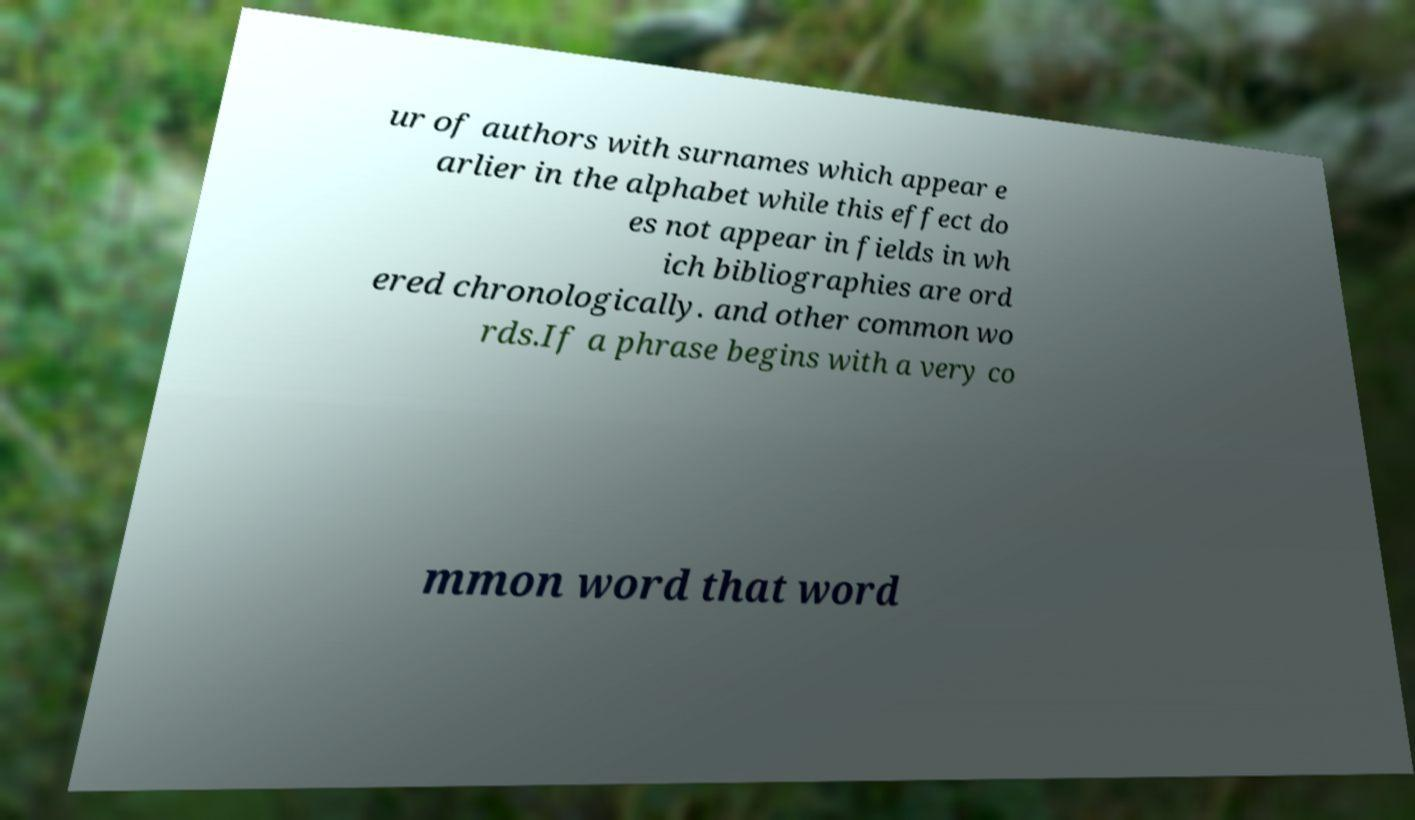Please read and relay the text visible in this image. What does it say? ur of authors with surnames which appear e arlier in the alphabet while this effect do es not appear in fields in wh ich bibliographies are ord ered chronologically. and other common wo rds.If a phrase begins with a very co mmon word that word 